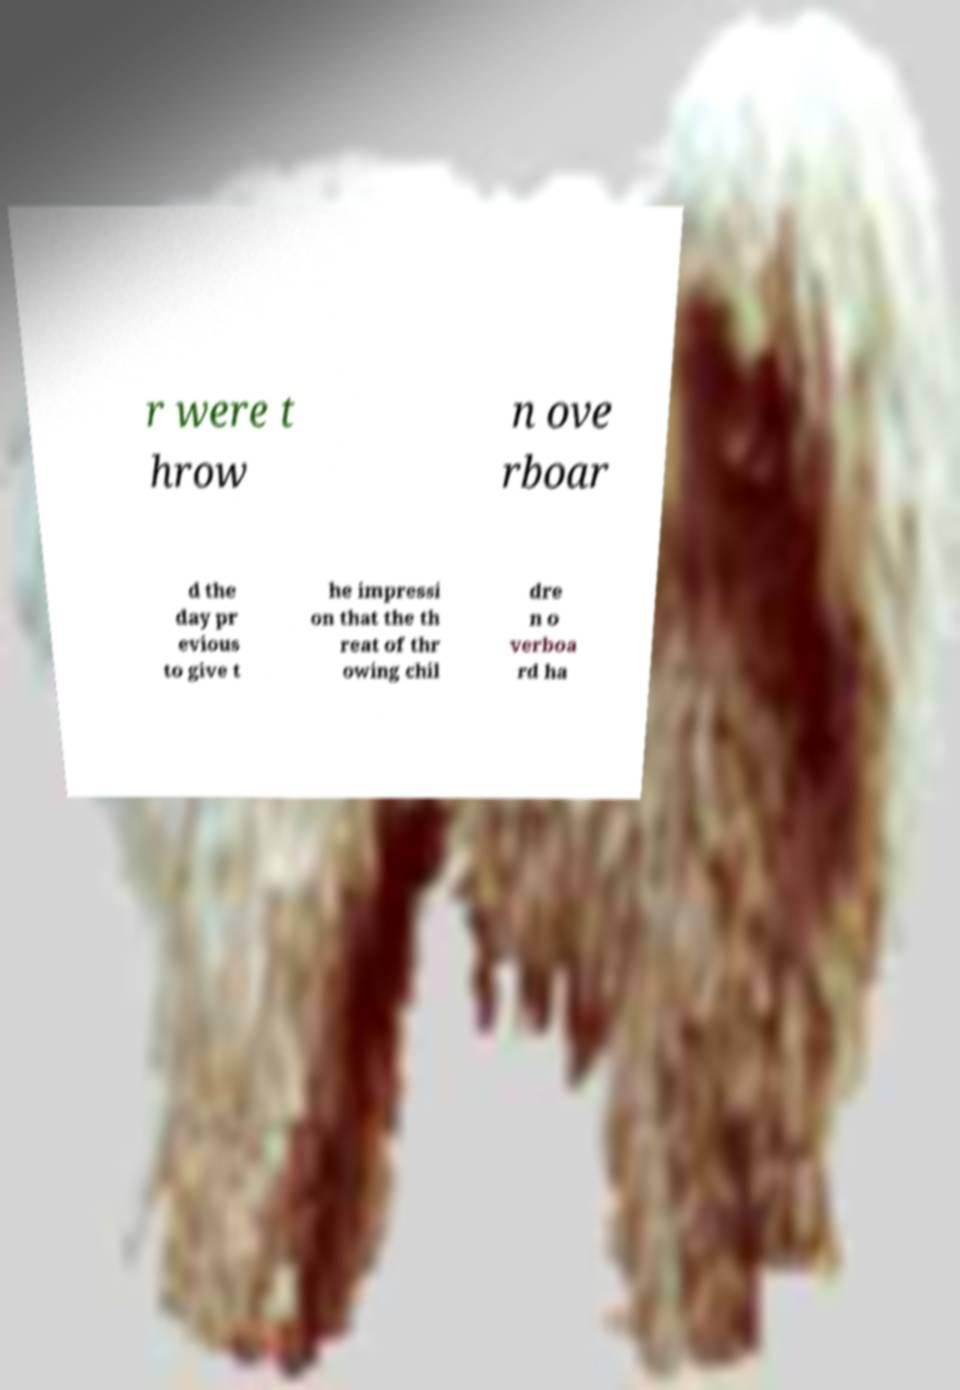For documentation purposes, I need the text within this image transcribed. Could you provide that? r were t hrow n ove rboar d the day pr evious to give t he impressi on that the th reat of thr owing chil dre n o verboa rd ha 